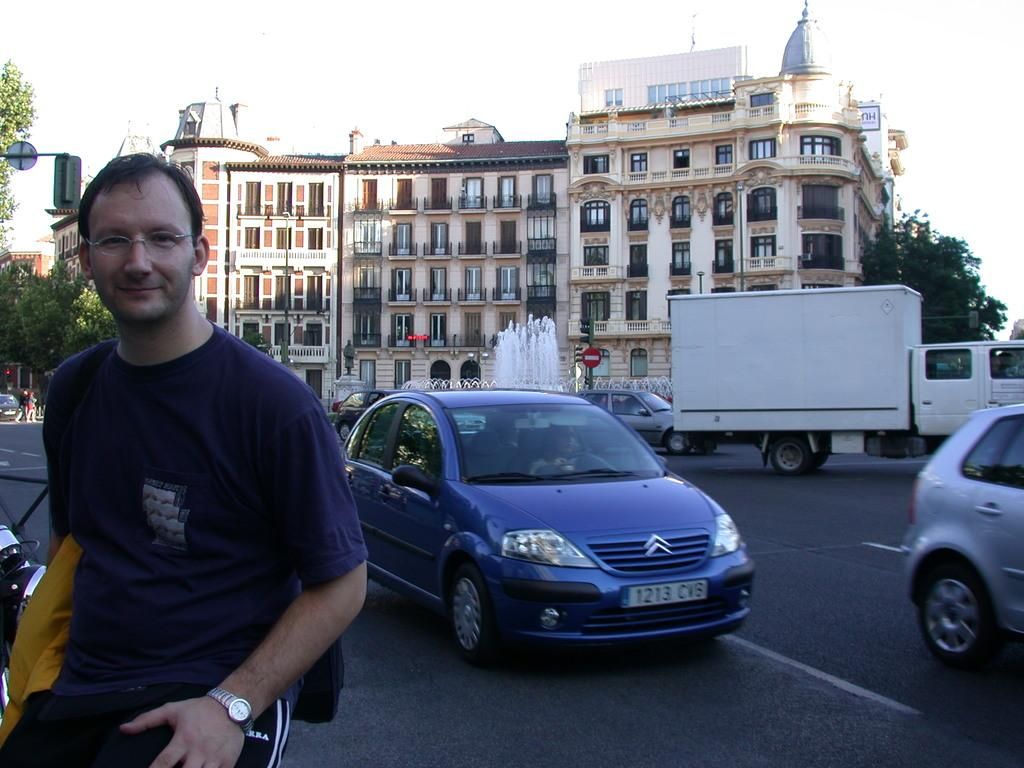Who is present in the image? There is a man in the image. What is the man wearing in the image? The man is wearing spectacles in the image. What can be seen on the road in the image? There are vehicles visible on the road in the image. What is visible in the background of the image? There are buildings, trees, and the sky visible in the background of the image. What type of jewel is the maid holding in the image? There is no maid or jewel present in the image. What flavor of jam is being served in the image? There is no jam present in the image. 